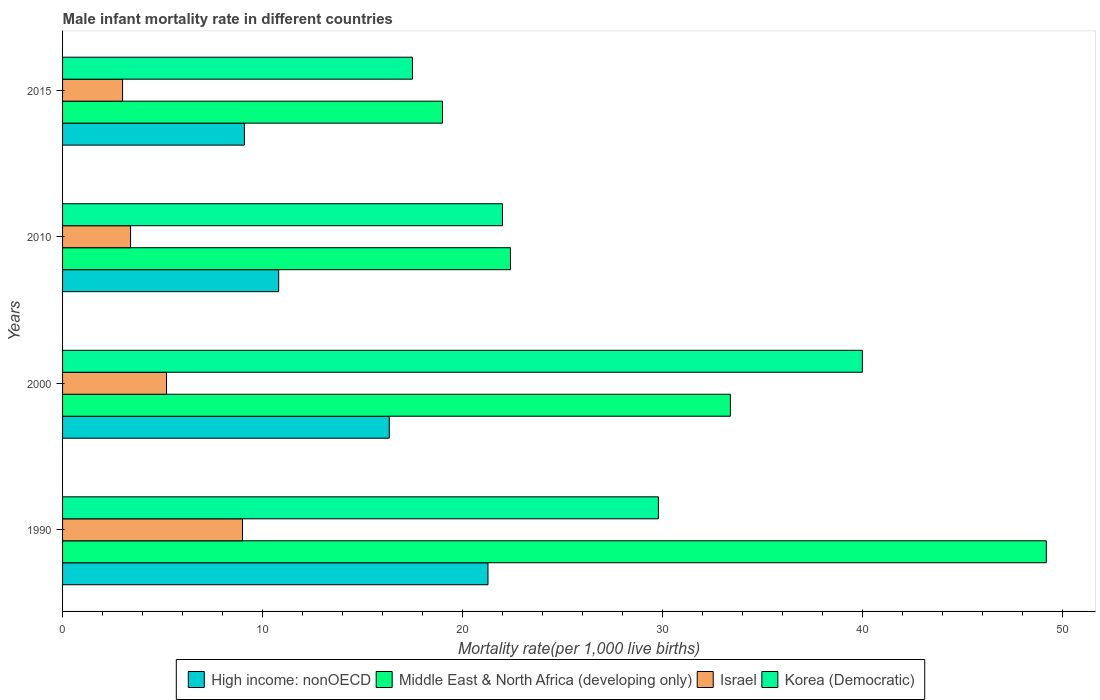How many different coloured bars are there?
Keep it short and to the point. 4. How many groups of bars are there?
Your answer should be compact. 4. How many bars are there on the 1st tick from the top?
Offer a very short reply. 4. What is the male infant mortality rate in High income: nonOECD in 2010?
Offer a terse response. 10.81. Across all years, what is the maximum male infant mortality rate in Israel?
Your response must be concise. 9. Across all years, what is the minimum male infant mortality rate in High income: nonOECD?
Provide a short and direct response. 9.09. In which year was the male infant mortality rate in Korea (Democratic) minimum?
Your answer should be compact. 2015. What is the total male infant mortality rate in High income: nonOECD in the graph?
Your answer should be very brief. 57.52. What is the difference between the male infant mortality rate in High income: nonOECD in 1990 and that in 2015?
Your answer should be compact. 12.18. What is the difference between the male infant mortality rate in High income: nonOECD in 1990 and the male infant mortality rate in Middle East & North Africa (developing only) in 2010?
Make the answer very short. -1.12. In the year 2000, what is the difference between the male infant mortality rate in Middle East & North Africa (developing only) and male infant mortality rate in Israel?
Offer a terse response. 28.2. What is the ratio of the male infant mortality rate in High income: nonOECD in 1990 to that in 2015?
Give a very brief answer. 2.34. What is the difference between the highest and the second highest male infant mortality rate in High income: nonOECD?
Offer a very short reply. 4.94. In how many years, is the male infant mortality rate in High income: nonOECD greater than the average male infant mortality rate in High income: nonOECD taken over all years?
Your response must be concise. 2. What does the 2nd bar from the top in 2015 represents?
Keep it short and to the point. Israel. How many bars are there?
Your answer should be compact. 16. Are all the bars in the graph horizontal?
Ensure brevity in your answer.  Yes. How many years are there in the graph?
Make the answer very short. 4. What is the difference between two consecutive major ticks on the X-axis?
Make the answer very short. 10. Are the values on the major ticks of X-axis written in scientific E-notation?
Give a very brief answer. No. Does the graph contain any zero values?
Offer a very short reply. No. Does the graph contain grids?
Give a very brief answer. No. What is the title of the graph?
Make the answer very short. Male infant mortality rate in different countries. What is the label or title of the X-axis?
Keep it short and to the point. Mortality rate(per 1,0 live births). What is the Mortality rate(per 1,000 live births) of High income: nonOECD in 1990?
Your answer should be compact. 21.28. What is the Mortality rate(per 1,000 live births) in Middle East & North Africa (developing only) in 1990?
Provide a short and direct response. 49.2. What is the Mortality rate(per 1,000 live births) of Israel in 1990?
Offer a terse response. 9. What is the Mortality rate(per 1,000 live births) in Korea (Democratic) in 1990?
Give a very brief answer. 29.8. What is the Mortality rate(per 1,000 live births) of High income: nonOECD in 2000?
Keep it short and to the point. 16.34. What is the Mortality rate(per 1,000 live births) of Middle East & North Africa (developing only) in 2000?
Provide a short and direct response. 33.4. What is the Mortality rate(per 1,000 live births) of Korea (Democratic) in 2000?
Give a very brief answer. 40. What is the Mortality rate(per 1,000 live births) of High income: nonOECD in 2010?
Offer a terse response. 10.81. What is the Mortality rate(per 1,000 live births) in Middle East & North Africa (developing only) in 2010?
Your answer should be compact. 22.4. What is the Mortality rate(per 1,000 live births) in Korea (Democratic) in 2010?
Provide a short and direct response. 22. What is the Mortality rate(per 1,000 live births) in High income: nonOECD in 2015?
Offer a terse response. 9.09. What is the Mortality rate(per 1,000 live births) of Middle East & North Africa (developing only) in 2015?
Keep it short and to the point. 19. What is the Mortality rate(per 1,000 live births) in Korea (Democratic) in 2015?
Make the answer very short. 17.5. Across all years, what is the maximum Mortality rate(per 1,000 live births) in High income: nonOECD?
Your response must be concise. 21.28. Across all years, what is the maximum Mortality rate(per 1,000 live births) in Middle East & North Africa (developing only)?
Provide a short and direct response. 49.2. Across all years, what is the maximum Mortality rate(per 1,000 live births) in Israel?
Offer a terse response. 9. Across all years, what is the maximum Mortality rate(per 1,000 live births) in Korea (Democratic)?
Your answer should be very brief. 40. Across all years, what is the minimum Mortality rate(per 1,000 live births) in High income: nonOECD?
Offer a very short reply. 9.09. Across all years, what is the minimum Mortality rate(per 1,000 live births) of Korea (Democratic)?
Keep it short and to the point. 17.5. What is the total Mortality rate(per 1,000 live births) in High income: nonOECD in the graph?
Provide a succinct answer. 57.52. What is the total Mortality rate(per 1,000 live births) in Middle East & North Africa (developing only) in the graph?
Offer a very short reply. 124. What is the total Mortality rate(per 1,000 live births) of Israel in the graph?
Your answer should be very brief. 20.6. What is the total Mortality rate(per 1,000 live births) in Korea (Democratic) in the graph?
Your answer should be compact. 109.3. What is the difference between the Mortality rate(per 1,000 live births) in High income: nonOECD in 1990 and that in 2000?
Provide a succinct answer. 4.94. What is the difference between the Mortality rate(per 1,000 live births) of Israel in 1990 and that in 2000?
Keep it short and to the point. 3.8. What is the difference between the Mortality rate(per 1,000 live births) of Korea (Democratic) in 1990 and that in 2000?
Provide a succinct answer. -10.2. What is the difference between the Mortality rate(per 1,000 live births) of High income: nonOECD in 1990 and that in 2010?
Give a very brief answer. 10.47. What is the difference between the Mortality rate(per 1,000 live births) of Middle East & North Africa (developing only) in 1990 and that in 2010?
Provide a short and direct response. 26.8. What is the difference between the Mortality rate(per 1,000 live births) of Israel in 1990 and that in 2010?
Ensure brevity in your answer.  5.6. What is the difference between the Mortality rate(per 1,000 live births) of High income: nonOECD in 1990 and that in 2015?
Your answer should be very brief. 12.18. What is the difference between the Mortality rate(per 1,000 live births) in Middle East & North Africa (developing only) in 1990 and that in 2015?
Your answer should be compact. 30.2. What is the difference between the Mortality rate(per 1,000 live births) of Korea (Democratic) in 1990 and that in 2015?
Your answer should be compact. 12.3. What is the difference between the Mortality rate(per 1,000 live births) of High income: nonOECD in 2000 and that in 2010?
Offer a terse response. 5.53. What is the difference between the Mortality rate(per 1,000 live births) of Middle East & North Africa (developing only) in 2000 and that in 2010?
Offer a terse response. 11. What is the difference between the Mortality rate(per 1,000 live births) in Israel in 2000 and that in 2010?
Ensure brevity in your answer.  1.8. What is the difference between the Mortality rate(per 1,000 live births) of Korea (Democratic) in 2000 and that in 2010?
Ensure brevity in your answer.  18. What is the difference between the Mortality rate(per 1,000 live births) of High income: nonOECD in 2000 and that in 2015?
Provide a short and direct response. 7.24. What is the difference between the Mortality rate(per 1,000 live births) in Israel in 2000 and that in 2015?
Offer a very short reply. 2.2. What is the difference between the Mortality rate(per 1,000 live births) of Korea (Democratic) in 2000 and that in 2015?
Provide a short and direct response. 22.5. What is the difference between the Mortality rate(per 1,000 live births) in High income: nonOECD in 2010 and that in 2015?
Keep it short and to the point. 1.71. What is the difference between the Mortality rate(per 1,000 live births) of Middle East & North Africa (developing only) in 2010 and that in 2015?
Keep it short and to the point. 3.4. What is the difference between the Mortality rate(per 1,000 live births) of Israel in 2010 and that in 2015?
Give a very brief answer. 0.4. What is the difference between the Mortality rate(per 1,000 live births) in High income: nonOECD in 1990 and the Mortality rate(per 1,000 live births) in Middle East & North Africa (developing only) in 2000?
Keep it short and to the point. -12.12. What is the difference between the Mortality rate(per 1,000 live births) in High income: nonOECD in 1990 and the Mortality rate(per 1,000 live births) in Israel in 2000?
Your answer should be very brief. 16.08. What is the difference between the Mortality rate(per 1,000 live births) of High income: nonOECD in 1990 and the Mortality rate(per 1,000 live births) of Korea (Democratic) in 2000?
Ensure brevity in your answer.  -18.72. What is the difference between the Mortality rate(per 1,000 live births) in Middle East & North Africa (developing only) in 1990 and the Mortality rate(per 1,000 live births) in Israel in 2000?
Provide a succinct answer. 44. What is the difference between the Mortality rate(per 1,000 live births) in Middle East & North Africa (developing only) in 1990 and the Mortality rate(per 1,000 live births) in Korea (Democratic) in 2000?
Provide a succinct answer. 9.2. What is the difference between the Mortality rate(per 1,000 live births) of Israel in 1990 and the Mortality rate(per 1,000 live births) of Korea (Democratic) in 2000?
Offer a very short reply. -31. What is the difference between the Mortality rate(per 1,000 live births) of High income: nonOECD in 1990 and the Mortality rate(per 1,000 live births) of Middle East & North Africa (developing only) in 2010?
Give a very brief answer. -1.12. What is the difference between the Mortality rate(per 1,000 live births) of High income: nonOECD in 1990 and the Mortality rate(per 1,000 live births) of Israel in 2010?
Provide a short and direct response. 17.88. What is the difference between the Mortality rate(per 1,000 live births) of High income: nonOECD in 1990 and the Mortality rate(per 1,000 live births) of Korea (Democratic) in 2010?
Offer a terse response. -0.72. What is the difference between the Mortality rate(per 1,000 live births) of Middle East & North Africa (developing only) in 1990 and the Mortality rate(per 1,000 live births) of Israel in 2010?
Provide a succinct answer. 45.8. What is the difference between the Mortality rate(per 1,000 live births) of Middle East & North Africa (developing only) in 1990 and the Mortality rate(per 1,000 live births) of Korea (Democratic) in 2010?
Give a very brief answer. 27.2. What is the difference between the Mortality rate(per 1,000 live births) in High income: nonOECD in 1990 and the Mortality rate(per 1,000 live births) in Middle East & North Africa (developing only) in 2015?
Your answer should be compact. 2.28. What is the difference between the Mortality rate(per 1,000 live births) in High income: nonOECD in 1990 and the Mortality rate(per 1,000 live births) in Israel in 2015?
Ensure brevity in your answer.  18.28. What is the difference between the Mortality rate(per 1,000 live births) of High income: nonOECD in 1990 and the Mortality rate(per 1,000 live births) of Korea (Democratic) in 2015?
Provide a succinct answer. 3.78. What is the difference between the Mortality rate(per 1,000 live births) of Middle East & North Africa (developing only) in 1990 and the Mortality rate(per 1,000 live births) of Israel in 2015?
Provide a short and direct response. 46.2. What is the difference between the Mortality rate(per 1,000 live births) of Middle East & North Africa (developing only) in 1990 and the Mortality rate(per 1,000 live births) of Korea (Democratic) in 2015?
Your answer should be compact. 31.7. What is the difference between the Mortality rate(per 1,000 live births) of High income: nonOECD in 2000 and the Mortality rate(per 1,000 live births) of Middle East & North Africa (developing only) in 2010?
Make the answer very short. -6.06. What is the difference between the Mortality rate(per 1,000 live births) of High income: nonOECD in 2000 and the Mortality rate(per 1,000 live births) of Israel in 2010?
Your answer should be very brief. 12.94. What is the difference between the Mortality rate(per 1,000 live births) in High income: nonOECD in 2000 and the Mortality rate(per 1,000 live births) in Korea (Democratic) in 2010?
Your answer should be compact. -5.66. What is the difference between the Mortality rate(per 1,000 live births) of Middle East & North Africa (developing only) in 2000 and the Mortality rate(per 1,000 live births) of Israel in 2010?
Provide a succinct answer. 30. What is the difference between the Mortality rate(per 1,000 live births) in Israel in 2000 and the Mortality rate(per 1,000 live births) in Korea (Democratic) in 2010?
Provide a succinct answer. -16.8. What is the difference between the Mortality rate(per 1,000 live births) of High income: nonOECD in 2000 and the Mortality rate(per 1,000 live births) of Middle East & North Africa (developing only) in 2015?
Offer a terse response. -2.66. What is the difference between the Mortality rate(per 1,000 live births) of High income: nonOECD in 2000 and the Mortality rate(per 1,000 live births) of Israel in 2015?
Give a very brief answer. 13.34. What is the difference between the Mortality rate(per 1,000 live births) of High income: nonOECD in 2000 and the Mortality rate(per 1,000 live births) of Korea (Democratic) in 2015?
Ensure brevity in your answer.  -1.16. What is the difference between the Mortality rate(per 1,000 live births) of Middle East & North Africa (developing only) in 2000 and the Mortality rate(per 1,000 live births) of Israel in 2015?
Your response must be concise. 30.4. What is the difference between the Mortality rate(per 1,000 live births) in High income: nonOECD in 2010 and the Mortality rate(per 1,000 live births) in Middle East & North Africa (developing only) in 2015?
Ensure brevity in your answer.  -8.19. What is the difference between the Mortality rate(per 1,000 live births) in High income: nonOECD in 2010 and the Mortality rate(per 1,000 live births) in Israel in 2015?
Provide a short and direct response. 7.81. What is the difference between the Mortality rate(per 1,000 live births) in High income: nonOECD in 2010 and the Mortality rate(per 1,000 live births) in Korea (Democratic) in 2015?
Your response must be concise. -6.69. What is the difference between the Mortality rate(per 1,000 live births) of Middle East & North Africa (developing only) in 2010 and the Mortality rate(per 1,000 live births) of Korea (Democratic) in 2015?
Your answer should be compact. 4.9. What is the difference between the Mortality rate(per 1,000 live births) in Israel in 2010 and the Mortality rate(per 1,000 live births) in Korea (Democratic) in 2015?
Offer a terse response. -14.1. What is the average Mortality rate(per 1,000 live births) in High income: nonOECD per year?
Give a very brief answer. 14.38. What is the average Mortality rate(per 1,000 live births) in Middle East & North Africa (developing only) per year?
Your answer should be compact. 31. What is the average Mortality rate(per 1,000 live births) in Israel per year?
Your answer should be very brief. 5.15. What is the average Mortality rate(per 1,000 live births) in Korea (Democratic) per year?
Your response must be concise. 27.32. In the year 1990, what is the difference between the Mortality rate(per 1,000 live births) of High income: nonOECD and Mortality rate(per 1,000 live births) of Middle East & North Africa (developing only)?
Provide a succinct answer. -27.92. In the year 1990, what is the difference between the Mortality rate(per 1,000 live births) of High income: nonOECD and Mortality rate(per 1,000 live births) of Israel?
Your answer should be compact. 12.28. In the year 1990, what is the difference between the Mortality rate(per 1,000 live births) of High income: nonOECD and Mortality rate(per 1,000 live births) of Korea (Democratic)?
Keep it short and to the point. -8.52. In the year 1990, what is the difference between the Mortality rate(per 1,000 live births) in Middle East & North Africa (developing only) and Mortality rate(per 1,000 live births) in Israel?
Give a very brief answer. 40.2. In the year 1990, what is the difference between the Mortality rate(per 1,000 live births) of Israel and Mortality rate(per 1,000 live births) of Korea (Democratic)?
Offer a very short reply. -20.8. In the year 2000, what is the difference between the Mortality rate(per 1,000 live births) of High income: nonOECD and Mortality rate(per 1,000 live births) of Middle East & North Africa (developing only)?
Offer a terse response. -17.06. In the year 2000, what is the difference between the Mortality rate(per 1,000 live births) of High income: nonOECD and Mortality rate(per 1,000 live births) of Israel?
Give a very brief answer. 11.14. In the year 2000, what is the difference between the Mortality rate(per 1,000 live births) in High income: nonOECD and Mortality rate(per 1,000 live births) in Korea (Democratic)?
Provide a short and direct response. -23.66. In the year 2000, what is the difference between the Mortality rate(per 1,000 live births) of Middle East & North Africa (developing only) and Mortality rate(per 1,000 live births) of Israel?
Make the answer very short. 28.2. In the year 2000, what is the difference between the Mortality rate(per 1,000 live births) in Israel and Mortality rate(per 1,000 live births) in Korea (Democratic)?
Offer a terse response. -34.8. In the year 2010, what is the difference between the Mortality rate(per 1,000 live births) of High income: nonOECD and Mortality rate(per 1,000 live births) of Middle East & North Africa (developing only)?
Your response must be concise. -11.59. In the year 2010, what is the difference between the Mortality rate(per 1,000 live births) in High income: nonOECD and Mortality rate(per 1,000 live births) in Israel?
Offer a terse response. 7.41. In the year 2010, what is the difference between the Mortality rate(per 1,000 live births) of High income: nonOECD and Mortality rate(per 1,000 live births) of Korea (Democratic)?
Keep it short and to the point. -11.19. In the year 2010, what is the difference between the Mortality rate(per 1,000 live births) of Israel and Mortality rate(per 1,000 live births) of Korea (Democratic)?
Give a very brief answer. -18.6. In the year 2015, what is the difference between the Mortality rate(per 1,000 live births) of High income: nonOECD and Mortality rate(per 1,000 live births) of Middle East & North Africa (developing only)?
Offer a very short reply. -9.91. In the year 2015, what is the difference between the Mortality rate(per 1,000 live births) of High income: nonOECD and Mortality rate(per 1,000 live births) of Israel?
Offer a terse response. 6.09. In the year 2015, what is the difference between the Mortality rate(per 1,000 live births) of High income: nonOECD and Mortality rate(per 1,000 live births) of Korea (Democratic)?
Your answer should be very brief. -8.41. In the year 2015, what is the difference between the Mortality rate(per 1,000 live births) of Israel and Mortality rate(per 1,000 live births) of Korea (Democratic)?
Give a very brief answer. -14.5. What is the ratio of the Mortality rate(per 1,000 live births) in High income: nonOECD in 1990 to that in 2000?
Make the answer very short. 1.3. What is the ratio of the Mortality rate(per 1,000 live births) in Middle East & North Africa (developing only) in 1990 to that in 2000?
Offer a very short reply. 1.47. What is the ratio of the Mortality rate(per 1,000 live births) in Israel in 1990 to that in 2000?
Your response must be concise. 1.73. What is the ratio of the Mortality rate(per 1,000 live births) of Korea (Democratic) in 1990 to that in 2000?
Your answer should be very brief. 0.74. What is the ratio of the Mortality rate(per 1,000 live births) of High income: nonOECD in 1990 to that in 2010?
Offer a very short reply. 1.97. What is the ratio of the Mortality rate(per 1,000 live births) in Middle East & North Africa (developing only) in 1990 to that in 2010?
Make the answer very short. 2.2. What is the ratio of the Mortality rate(per 1,000 live births) of Israel in 1990 to that in 2010?
Offer a terse response. 2.65. What is the ratio of the Mortality rate(per 1,000 live births) of Korea (Democratic) in 1990 to that in 2010?
Provide a short and direct response. 1.35. What is the ratio of the Mortality rate(per 1,000 live births) in High income: nonOECD in 1990 to that in 2015?
Your answer should be compact. 2.34. What is the ratio of the Mortality rate(per 1,000 live births) of Middle East & North Africa (developing only) in 1990 to that in 2015?
Your answer should be very brief. 2.59. What is the ratio of the Mortality rate(per 1,000 live births) in Israel in 1990 to that in 2015?
Ensure brevity in your answer.  3. What is the ratio of the Mortality rate(per 1,000 live births) in Korea (Democratic) in 1990 to that in 2015?
Give a very brief answer. 1.7. What is the ratio of the Mortality rate(per 1,000 live births) of High income: nonOECD in 2000 to that in 2010?
Give a very brief answer. 1.51. What is the ratio of the Mortality rate(per 1,000 live births) in Middle East & North Africa (developing only) in 2000 to that in 2010?
Your response must be concise. 1.49. What is the ratio of the Mortality rate(per 1,000 live births) of Israel in 2000 to that in 2010?
Make the answer very short. 1.53. What is the ratio of the Mortality rate(per 1,000 live births) of Korea (Democratic) in 2000 to that in 2010?
Your answer should be compact. 1.82. What is the ratio of the Mortality rate(per 1,000 live births) of High income: nonOECD in 2000 to that in 2015?
Give a very brief answer. 1.8. What is the ratio of the Mortality rate(per 1,000 live births) of Middle East & North Africa (developing only) in 2000 to that in 2015?
Provide a short and direct response. 1.76. What is the ratio of the Mortality rate(per 1,000 live births) in Israel in 2000 to that in 2015?
Provide a short and direct response. 1.73. What is the ratio of the Mortality rate(per 1,000 live births) of Korea (Democratic) in 2000 to that in 2015?
Offer a very short reply. 2.29. What is the ratio of the Mortality rate(per 1,000 live births) in High income: nonOECD in 2010 to that in 2015?
Give a very brief answer. 1.19. What is the ratio of the Mortality rate(per 1,000 live births) of Middle East & North Africa (developing only) in 2010 to that in 2015?
Offer a terse response. 1.18. What is the ratio of the Mortality rate(per 1,000 live births) in Israel in 2010 to that in 2015?
Provide a short and direct response. 1.13. What is the ratio of the Mortality rate(per 1,000 live births) of Korea (Democratic) in 2010 to that in 2015?
Provide a succinct answer. 1.26. What is the difference between the highest and the second highest Mortality rate(per 1,000 live births) in High income: nonOECD?
Provide a succinct answer. 4.94. What is the difference between the highest and the second highest Mortality rate(per 1,000 live births) in Middle East & North Africa (developing only)?
Your answer should be very brief. 15.8. What is the difference between the highest and the second highest Mortality rate(per 1,000 live births) in Israel?
Your response must be concise. 3.8. What is the difference between the highest and the lowest Mortality rate(per 1,000 live births) in High income: nonOECD?
Ensure brevity in your answer.  12.18. What is the difference between the highest and the lowest Mortality rate(per 1,000 live births) in Middle East & North Africa (developing only)?
Ensure brevity in your answer.  30.2. 